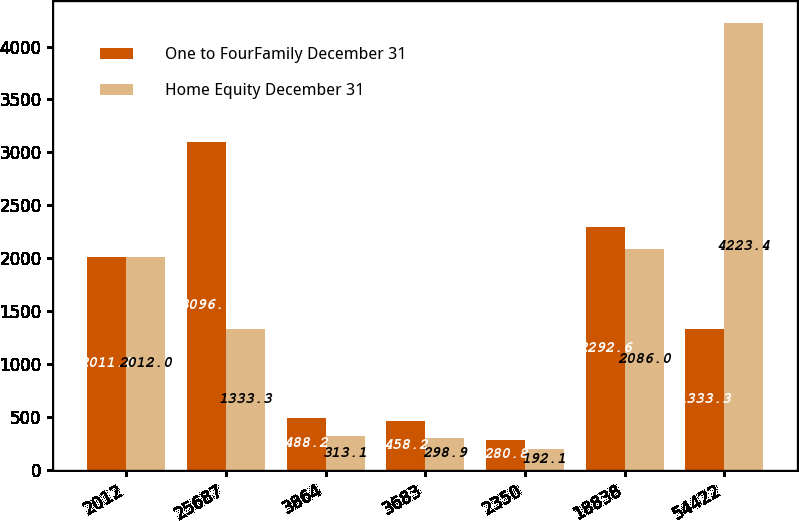<chart> <loc_0><loc_0><loc_500><loc_500><stacked_bar_chart><ecel><fcel>2012<fcel>25687<fcel>3864<fcel>3683<fcel>2350<fcel>18838<fcel>54422<nl><fcel>One to FourFamily December 31<fcel>2011<fcel>3096<fcel>488.2<fcel>458.2<fcel>280.8<fcel>2292.6<fcel>1333.3<nl><fcel>Home Equity December 31<fcel>2012<fcel>1333.3<fcel>313.1<fcel>298.9<fcel>192.1<fcel>2086<fcel>4223.4<nl></chart> 